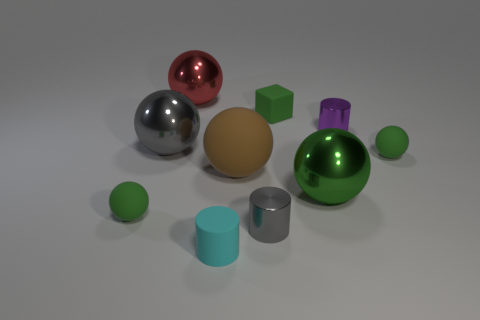There is a green matte object behind the tiny rubber sphere that is behind the big metallic thing that is to the right of the big red shiny object; what is its size?
Provide a succinct answer. Small. Does the brown object have the same size as the cube?
Keep it short and to the point. No. There is a tiny metallic thing to the left of the purple cylinder; does it have the same shape as the green object behind the purple thing?
Your answer should be very brief. No. There is a green thing on the right side of the small purple metal cylinder; are there any tiny green objects that are behind it?
Provide a succinct answer. Yes. Are any cyan things visible?
Provide a short and direct response. Yes. What number of metal cylinders have the same size as the block?
Keep it short and to the point. 2. What number of small cylinders are both in front of the purple cylinder and on the right side of the brown object?
Your answer should be compact. 1. Does the shiny sphere that is behind the green rubber cube have the same size as the big green shiny thing?
Give a very brief answer. Yes. Are there any other matte cubes of the same color as the tiny cube?
Your answer should be very brief. No. There is a gray cylinder that is the same material as the red ball; what size is it?
Your response must be concise. Small. 